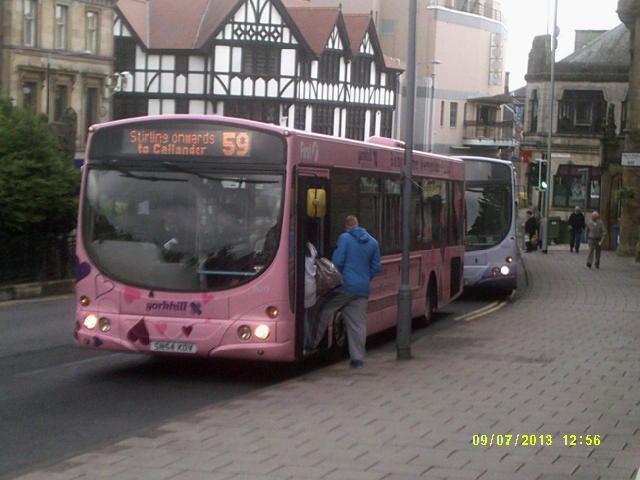What time was the photo taken?
Keep it brief. 12:56. What does the front of the bus say?
Concise answer only. Stirling onwards to calendar. How many people are boarding the bus?
Write a very short answer. 2. Is anyone getting on the bus?
Be succinct. Yes. What is white and brown?
Answer briefly. Building. 